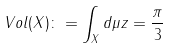<formula> <loc_0><loc_0><loc_500><loc_500>V o l ( X ) \colon = \int _ { X } d \mu z = \frac { \pi } { 3 }</formula> 